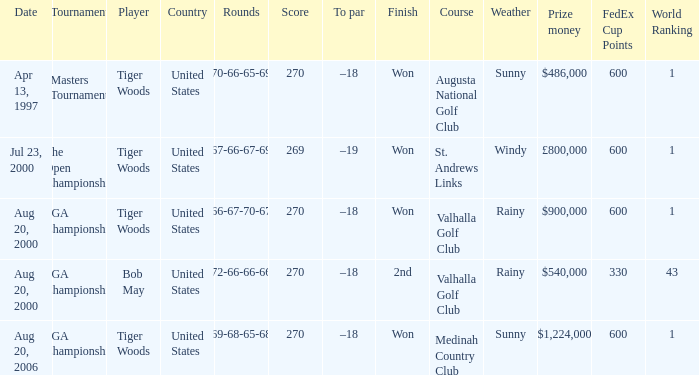Write the full table. {'header': ['Date', 'Tournament', 'Player', 'Country', 'Rounds', 'Score', 'To par', 'Finish', 'Course', 'Weather', 'Prize money', 'FedEx Cup Points', 'World Ranking'], 'rows': [['Apr 13, 1997', 'Masters Tournament', 'Tiger Woods', 'United States', '70-66-65-69', '270', '–18', 'Won', 'Augusta National Golf Club', 'Sunny', '$486,000', '600', '1'], ['Jul 23, 2000', 'The Open Championship', 'Tiger Woods', 'United States', '67-66-67-69', '269', '–19', 'Won', 'St. Andrews Links', 'Windy', '£800,000', '600', '1'], ['Aug 20, 2000', 'PGA Championship', 'Tiger Woods', 'United States', '66-67-70-67', '270', '–18', 'Won', 'Valhalla Golf Club', 'Rainy', '$900,000', '600', '1'], ['Aug 20, 2000', 'PGA Championship', 'Bob May', 'United States', '72-66-66-66', '270', '–18', '2nd', 'Valhalla Golf Club', 'Rainy', '$540,000', '330', '43'], ['Aug 20, 2006', 'PGA Championship', 'Tiger Woods', 'United States', '69-68-65-68', '270', '–18', 'Won', 'Medinah Country Club', 'Sunny', '$1,224,000', '600', '1']]} What country hosts the tournament the open championship? United States. 